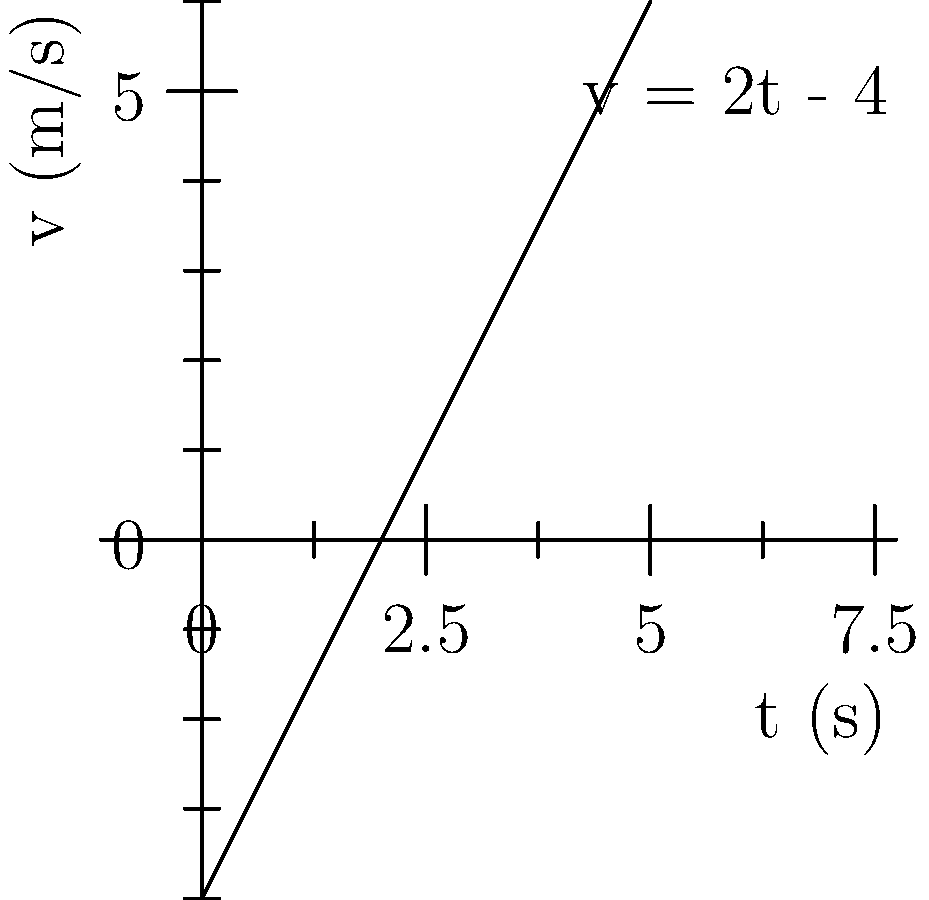A particle's velocity (in m/s) is given by the function $v(t) = 2t - 4$, where $t$ is time in seconds. The graph of this function is shown above. Determine the particle's displacement between $t = 1$ and $t = 3$ seconds. To find the displacement, we need to calculate the area under the velocity-time graph between $t = 1$ and $t = 3$. This area represents the change in position (displacement) of the particle.

Step 1: Set up the integral
$$\text{Displacement} = \int_{1}^{3} (2t - 4) dt$$

Step 2: Evaluate the integral
$$\begin{align*}
\text{Displacement} &= \left[t^2 - 4t\right]_{1}^{3} \\
&= (3^2 - 4(3)) - (1^2 - 4(1)) \\
&= (9 - 12) - (1 - 4) \\
&= -3 - (-3) \\
&= 0
\end{align*}$$

Step 3: Interpret the result
The displacement is 0 meters, which means the particle returns to its initial position after 2 seconds.
Answer: 0 m 